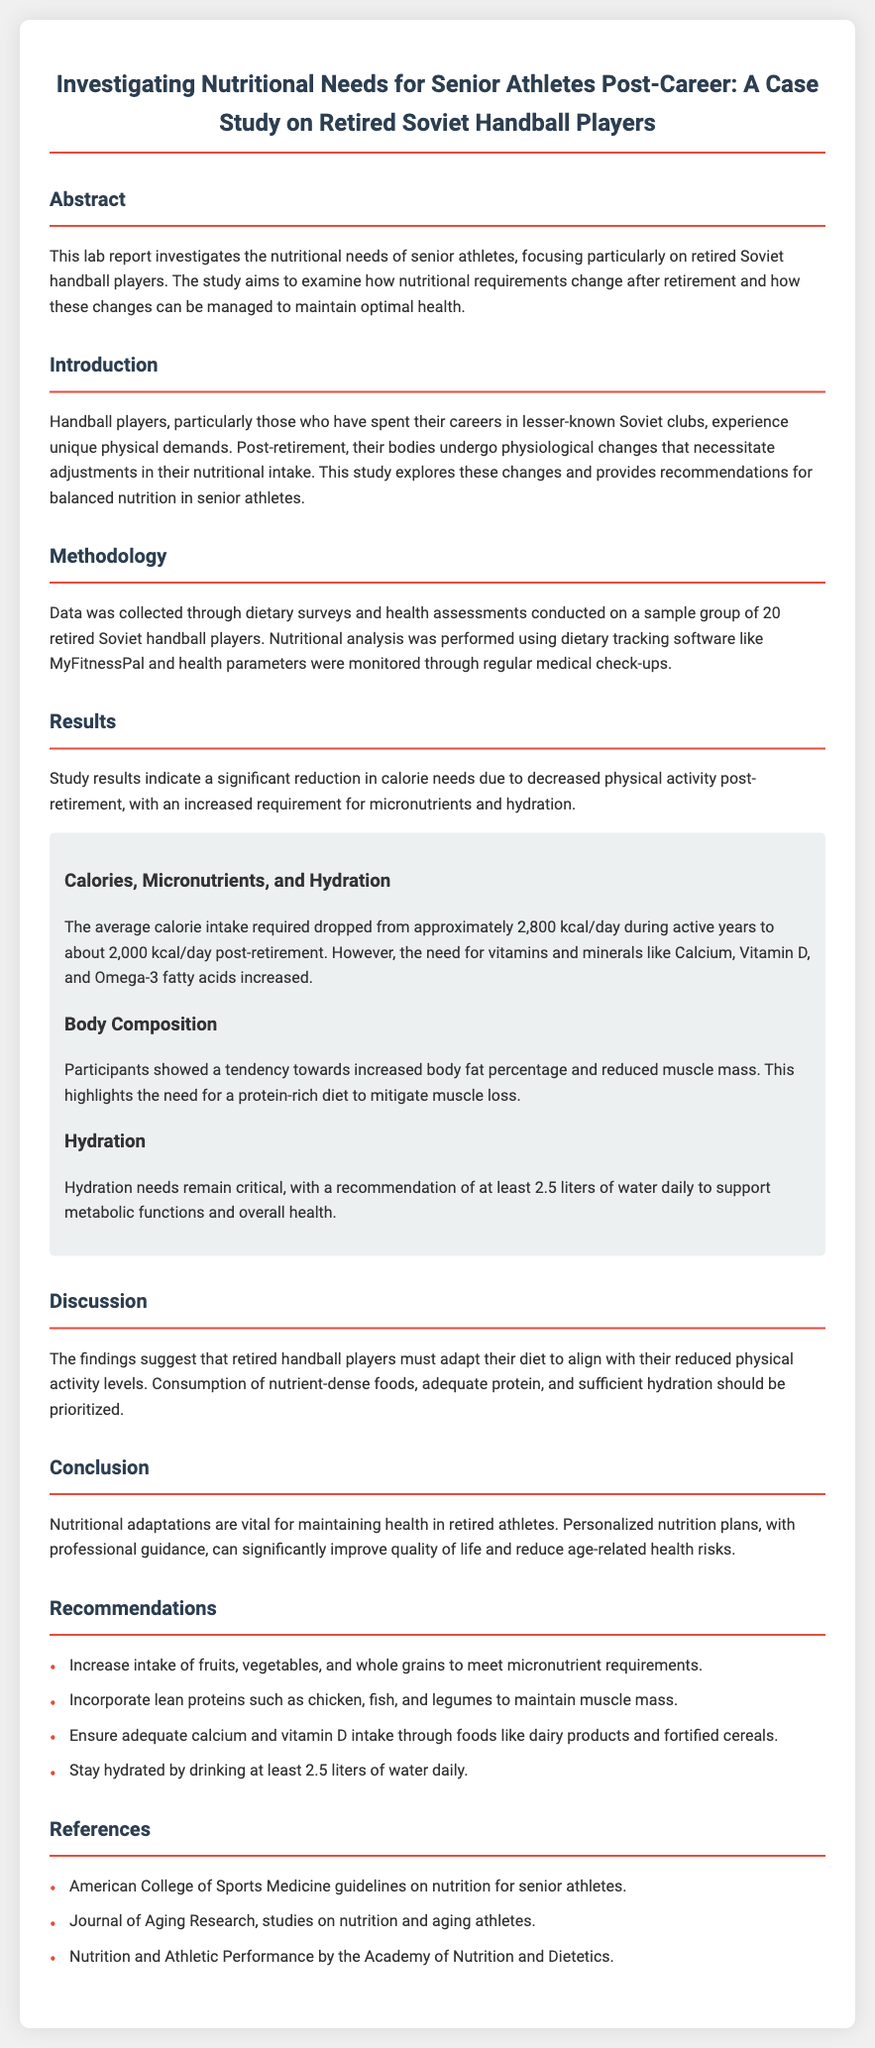What is the focus of the study? The study focuses on the nutritional needs of senior athletes, specifically retired Soviet handball players.
Answer: Nutritional needs for senior athletes What is the average calorie intake required post-retirement? The report provides the average calorie intake required post-retirement, which is stated explicitly in the results section.
Answer: 2000 kcal/day Which micronutrients increased in requirement? The document lists specific micronutrients whose needs increased after retirement, found in the results section.
Answer: Calcium, Vitamin D, Omega-3 fatty acids What is the recommended daily water intake? The report specifies hydration needs and provides a daily water intake recommendation in the results section.
Answer: 2.5 liters What type of foods should be increased in intake? Recommendations for diet include specific types of foods; this information is found in the recommendations section.
Answer: Fruits, vegetables, whole grains Why is protein consumption emphasized? The emphasis on protein consumption is discussed in relation to body composition changes post-retirement, particularly concerning muscle mass.
Answer: To maintain muscle mass What methodology was used for data collection? The methodology section details the methods used for data collection in the study.
Answer: Dietary surveys and health assessments What is a key recommendation for hydration? The recommendations section promotes a specific hydration guideline, aiming to support overall health.
Answer: Drink at least 2.5 liters of water daily What type of analysis was performed on the data? The analysis type is mentioned in the methodology section, describing how the dietary intake was assessed.
Answer: Nutritional analysis using dietary tracking software 